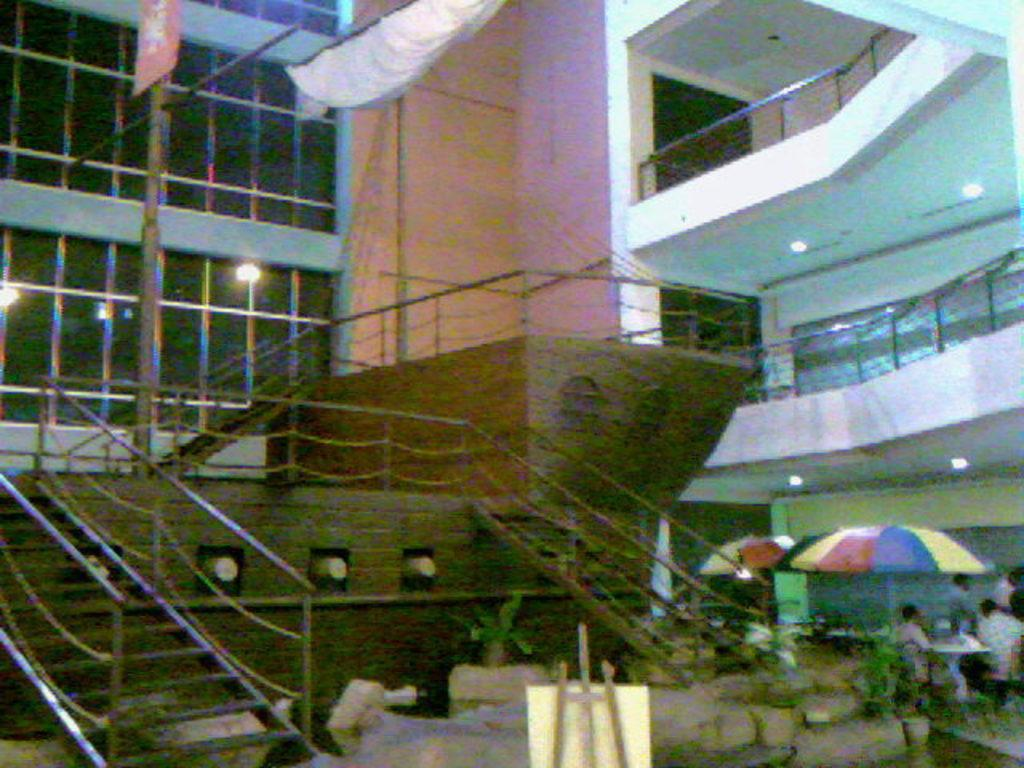What type of structure can be seen in the image? There are stairs and a wall in the background of the image. What is located near the stairs? There is a wooden boat in the image. What object can be seen in the foreground of the image? There is a board in the image. What type of vegetation is present in the image? There are plants in the image. What items are used for protection from the sun or rain in the image? There are umbrellas in the image. What is the paper standing for in the image? There is a paper standing in the image, but its purpose is not clear from the facts provided. What type of building can be seen in the image? There is a glass building in the image. What type of gold object is visible in the image? There is no gold object present in the image. How does the wooden boat move in the image? The wooden boat does not move in the image; it is stationary. What type of transport is used to travel in the image? There is no transport visible in the image. 